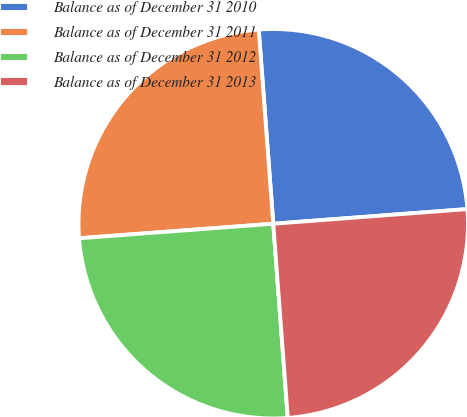<chart> <loc_0><loc_0><loc_500><loc_500><pie_chart><fcel>Balance as of December 31 2010<fcel>Balance as of December 31 2011<fcel>Balance as of December 31 2012<fcel>Balance as of December 31 2013<nl><fcel>24.99%<fcel>25.0%<fcel>25.0%<fcel>25.01%<nl></chart> 